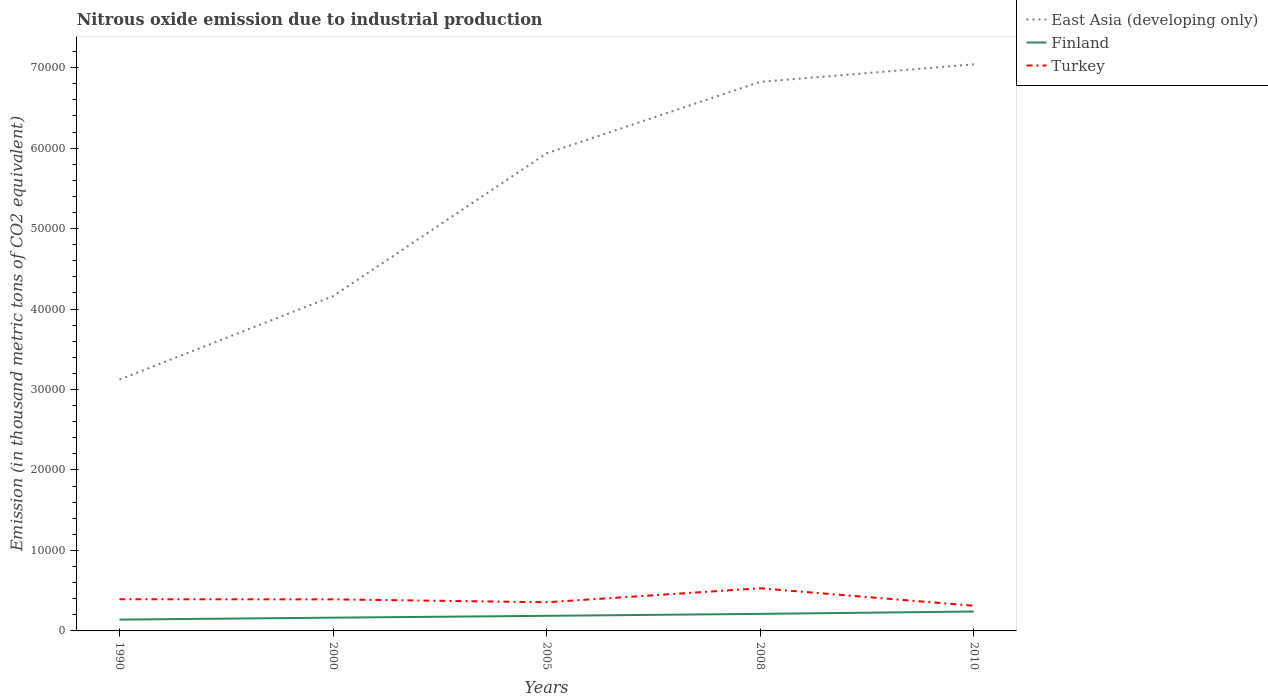How many different coloured lines are there?
Offer a terse response. 3. Does the line corresponding to Finland intersect with the line corresponding to Turkey?
Offer a terse response. No. Across all years, what is the maximum amount of nitrous oxide emitted in Turkey?
Make the answer very short. 3127.4. In which year was the amount of nitrous oxide emitted in Turkey maximum?
Your answer should be compact. 2010. What is the total amount of nitrous oxide emitted in Turkey in the graph?
Make the answer very short. 2172.9. What is the difference between the highest and the second highest amount of nitrous oxide emitted in Turkey?
Your answer should be compact. 2172.9. Is the amount of nitrous oxide emitted in Turkey strictly greater than the amount of nitrous oxide emitted in East Asia (developing only) over the years?
Make the answer very short. Yes. What is the difference between two consecutive major ticks on the Y-axis?
Your answer should be compact. 10000. Where does the legend appear in the graph?
Provide a short and direct response. Top right. What is the title of the graph?
Offer a terse response. Nitrous oxide emission due to industrial production. Does "Trinidad and Tobago" appear as one of the legend labels in the graph?
Keep it short and to the point. No. What is the label or title of the X-axis?
Make the answer very short. Years. What is the label or title of the Y-axis?
Give a very brief answer. Emission (in thousand metric tons of CO2 equivalent). What is the Emission (in thousand metric tons of CO2 equivalent) in East Asia (developing only) in 1990?
Make the answer very short. 3.12e+04. What is the Emission (in thousand metric tons of CO2 equivalent) in Finland in 1990?
Make the answer very short. 1406.8. What is the Emission (in thousand metric tons of CO2 equivalent) in Turkey in 1990?
Ensure brevity in your answer.  3938.1. What is the Emission (in thousand metric tons of CO2 equivalent) in East Asia (developing only) in 2000?
Offer a terse response. 4.16e+04. What is the Emission (in thousand metric tons of CO2 equivalent) of Finland in 2000?
Make the answer very short. 1648.4. What is the Emission (in thousand metric tons of CO2 equivalent) of Turkey in 2000?
Your response must be concise. 3923.9. What is the Emission (in thousand metric tons of CO2 equivalent) in East Asia (developing only) in 2005?
Ensure brevity in your answer.  5.94e+04. What is the Emission (in thousand metric tons of CO2 equivalent) in Finland in 2005?
Offer a very short reply. 1876.3. What is the Emission (in thousand metric tons of CO2 equivalent) of Turkey in 2005?
Give a very brief answer. 3561.4. What is the Emission (in thousand metric tons of CO2 equivalent) in East Asia (developing only) in 2008?
Your response must be concise. 6.82e+04. What is the Emission (in thousand metric tons of CO2 equivalent) in Finland in 2008?
Offer a terse response. 2118.7. What is the Emission (in thousand metric tons of CO2 equivalent) of Turkey in 2008?
Provide a short and direct response. 5300.3. What is the Emission (in thousand metric tons of CO2 equivalent) in East Asia (developing only) in 2010?
Your answer should be compact. 7.04e+04. What is the Emission (in thousand metric tons of CO2 equivalent) of Finland in 2010?
Offer a terse response. 2412.4. What is the Emission (in thousand metric tons of CO2 equivalent) in Turkey in 2010?
Provide a short and direct response. 3127.4. Across all years, what is the maximum Emission (in thousand metric tons of CO2 equivalent) in East Asia (developing only)?
Ensure brevity in your answer.  7.04e+04. Across all years, what is the maximum Emission (in thousand metric tons of CO2 equivalent) of Finland?
Provide a short and direct response. 2412.4. Across all years, what is the maximum Emission (in thousand metric tons of CO2 equivalent) in Turkey?
Give a very brief answer. 5300.3. Across all years, what is the minimum Emission (in thousand metric tons of CO2 equivalent) in East Asia (developing only)?
Offer a terse response. 3.12e+04. Across all years, what is the minimum Emission (in thousand metric tons of CO2 equivalent) of Finland?
Your answer should be very brief. 1406.8. Across all years, what is the minimum Emission (in thousand metric tons of CO2 equivalent) of Turkey?
Provide a short and direct response. 3127.4. What is the total Emission (in thousand metric tons of CO2 equivalent) of East Asia (developing only) in the graph?
Your answer should be compact. 2.71e+05. What is the total Emission (in thousand metric tons of CO2 equivalent) in Finland in the graph?
Offer a very short reply. 9462.6. What is the total Emission (in thousand metric tons of CO2 equivalent) of Turkey in the graph?
Your answer should be very brief. 1.99e+04. What is the difference between the Emission (in thousand metric tons of CO2 equivalent) of East Asia (developing only) in 1990 and that in 2000?
Provide a short and direct response. -1.04e+04. What is the difference between the Emission (in thousand metric tons of CO2 equivalent) of Finland in 1990 and that in 2000?
Provide a short and direct response. -241.6. What is the difference between the Emission (in thousand metric tons of CO2 equivalent) in East Asia (developing only) in 1990 and that in 2005?
Your response must be concise. -2.81e+04. What is the difference between the Emission (in thousand metric tons of CO2 equivalent) of Finland in 1990 and that in 2005?
Your response must be concise. -469.5. What is the difference between the Emission (in thousand metric tons of CO2 equivalent) in Turkey in 1990 and that in 2005?
Offer a terse response. 376.7. What is the difference between the Emission (in thousand metric tons of CO2 equivalent) in East Asia (developing only) in 1990 and that in 2008?
Your answer should be very brief. -3.70e+04. What is the difference between the Emission (in thousand metric tons of CO2 equivalent) of Finland in 1990 and that in 2008?
Keep it short and to the point. -711.9. What is the difference between the Emission (in thousand metric tons of CO2 equivalent) in Turkey in 1990 and that in 2008?
Offer a very short reply. -1362.2. What is the difference between the Emission (in thousand metric tons of CO2 equivalent) of East Asia (developing only) in 1990 and that in 2010?
Your answer should be compact. -3.92e+04. What is the difference between the Emission (in thousand metric tons of CO2 equivalent) in Finland in 1990 and that in 2010?
Give a very brief answer. -1005.6. What is the difference between the Emission (in thousand metric tons of CO2 equivalent) in Turkey in 1990 and that in 2010?
Provide a succinct answer. 810.7. What is the difference between the Emission (in thousand metric tons of CO2 equivalent) of East Asia (developing only) in 2000 and that in 2005?
Ensure brevity in your answer.  -1.78e+04. What is the difference between the Emission (in thousand metric tons of CO2 equivalent) of Finland in 2000 and that in 2005?
Provide a succinct answer. -227.9. What is the difference between the Emission (in thousand metric tons of CO2 equivalent) of Turkey in 2000 and that in 2005?
Keep it short and to the point. 362.5. What is the difference between the Emission (in thousand metric tons of CO2 equivalent) in East Asia (developing only) in 2000 and that in 2008?
Make the answer very short. -2.66e+04. What is the difference between the Emission (in thousand metric tons of CO2 equivalent) of Finland in 2000 and that in 2008?
Your answer should be very brief. -470.3. What is the difference between the Emission (in thousand metric tons of CO2 equivalent) of Turkey in 2000 and that in 2008?
Ensure brevity in your answer.  -1376.4. What is the difference between the Emission (in thousand metric tons of CO2 equivalent) in East Asia (developing only) in 2000 and that in 2010?
Make the answer very short. -2.88e+04. What is the difference between the Emission (in thousand metric tons of CO2 equivalent) of Finland in 2000 and that in 2010?
Give a very brief answer. -764. What is the difference between the Emission (in thousand metric tons of CO2 equivalent) in Turkey in 2000 and that in 2010?
Provide a short and direct response. 796.5. What is the difference between the Emission (in thousand metric tons of CO2 equivalent) of East Asia (developing only) in 2005 and that in 2008?
Ensure brevity in your answer.  -8880.6. What is the difference between the Emission (in thousand metric tons of CO2 equivalent) of Finland in 2005 and that in 2008?
Keep it short and to the point. -242.4. What is the difference between the Emission (in thousand metric tons of CO2 equivalent) of Turkey in 2005 and that in 2008?
Make the answer very short. -1738.9. What is the difference between the Emission (in thousand metric tons of CO2 equivalent) in East Asia (developing only) in 2005 and that in 2010?
Your response must be concise. -1.11e+04. What is the difference between the Emission (in thousand metric tons of CO2 equivalent) of Finland in 2005 and that in 2010?
Give a very brief answer. -536.1. What is the difference between the Emission (in thousand metric tons of CO2 equivalent) in Turkey in 2005 and that in 2010?
Provide a short and direct response. 434. What is the difference between the Emission (in thousand metric tons of CO2 equivalent) of East Asia (developing only) in 2008 and that in 2010?
Your answer should be compact. -2177.7. What is the difference between the Emission (in thousand metric tons of CO2 equivalent) of Finland in 2008 and that in 2010?
Give a very brief answer. -293.7. What is the difference between the Emission (in thousand metric tons of CO2 equivalent) of Turkey in 2008 and that in 2010?
Give a very brief answer. 2172.9. What is the difference between the Emission (in thousand metric tons of CO2 equivalent) in East Asia (developing only) in 1990 and the Emission (in thousand metric tons of CO2 equivalent) in Finland in 2000?
Your response must be concise. 2.96e+04. What is the difference between the Emission (in thousand metric tons of CO2 equivalent) in East Asia (developing only) in 1990 and the Emission (in thousand metric tons of CO2 equivalent) in Turkey in 2000?
Give a very brief answer. 2.73e+04. What is the difference between the Emission (in thousand metric tons of CO2 equivalent) in Finland in 1990 and the Emission (in thousand metric tons of CO2 equivalent) in Turkey in 2000?
Provide a short and direct response. -2517.1. What is the difference between the Emission (in thousand metric tons of CO2 equivalent) in East Asia (developing only) in 1990 and the Emission (in thousand metric tons of CO2 equivalent) in Finland in 2005?
Offer a very short reply. 2.94e+04. What is the difference between the Emission (in thousand metric tons of CO2 equivalent) of East Asia (developing only) in 1990 and the Emission (in thousand metric tons of CO2 equivalent) of Turkey in 2005?
Your response must be concise. 2.77e+04. What is the difference between the Emission (in thousand metric tons of CO2 equivalent) of Finland in 1990 and the Emission (in thousand metric tons of CO2 equivalent) of Turkey in 2005?
Your answer should be compact. -2154.6. What is the difference between the Emission (in thousand metric tons of CO2 equivalent) in East Asia (developing only) in 1990 and the Emission (in thousand metric tons of CO2 equivalent) in Finland in 2008?
Offer a very short reply. 2.91e+04. What is the difference between the Emission (in thousand metric tons of CO2 equivalent) of East Asia (developing only) in 1990 and the Emission (in thousand metric tons of CO2 equivalent) of Turkey in 2008?
Your response must be concise. 2.59e+04. What is the difference between the Emission (in thousand metric tons of CO2 equivalent) of Finland in 1990 and the Emission (in thousand metric tons of CO2 equivalent) of Turkey in 2008?
Provide a short and direct response. -3893.5. What is the difference between the Emission (in thousand metric tons of CO2 equivalent) in East Asia (developing only) in 1990 and the Emission (in thousand metric tons of CO2 equivalent) in Finland in 2010?
Give a very brief answer. 2.88e+04. What is the difference between the Emission (in thousand metric tons of CO2 equivalent) of East Asia (developing only) in 1990 and the Emission (in thousand metric tons of CO2 equivalent) of Turkey in 2010?
Make the answer very short. 2.81e+04. What is the difference between the Emission (in thousand metric tons of CO2 equivalent) of Finland in 1990 and the Emission (in thousand metric tons of CO2 equivalent) of Turkey in 2010?
Provide a succinct answer. -1720.6. What is the difference between the Emission (in thousand metric tons of CO2 equivalent) in East Asia (developing only) in 2000 and the Emission (in thousand metric tons of CO2 equivalent) in Finland in 2005?
Give a very brief answer. 3.97e+04. What is the difference between the Emission (in thousand metric tons of CO2 equivalent) of East Asia (developing only) in 2000 and the Emission (in thousand metric tons of CO2 equivalent) of Turkey in 2005?
Make the answer very short. 3.80e+04. What is the difference between the Emission (in thousand metric tons of CO2 equivalent) of Finland in 2000 and the Emission (in thousand metric tons of CO2 equivalent) of Turkey in 2005?
Your answer should be very brief. -1913. What is the difference between the Emission (in thousand metric tons of CO2 equivalent) in East Asia (developing only) in 2000 and the Emission (in thousand metric tons of CO2 equivalent) in Finland in 2008?
Keep it short and to the point. 3.95e+04. What is the difference between the Emission (in thousand metric tons of CO2 equivalent) in East Asia (developing only) in 2000 and the Emission (in thousand metric tons of CO2 equivalent) in Turkey in 2008?
Keep it short and to the point. 3.63e+04. What is the difference between the Emission (in thousand metric tons of CO2 equivalent) in Finland in 2000 and the Emission (in thousand metric tons of CO2 equivalent) in Turkey in 2008?
Your response must be concise. -3651.9. What is the difference between the Emission (in thousand metric tons of CO2 equivalent) in East Asia (developing only) in 2000 and the Emission (in thousand metric tons of CO2 equivalent) in Finland in 2010?
Offer a terse response. 3.92e+04. What is the difference between the Emission (in thousand metric tons of CO2 equivalent) of East Asia (developing only) in 2000 and the Emission (in thousand metric tons of CO2 equivalent) of Turkey in 2010?
Provide a short and direct response. 3.85e+04. What is the difference between the Emission (in thousand metric tons of CO2 equivalent) of Finland in 2000 and the Emission (in thousand metric tons of CO2 equivalent) of Turkey in 2010?
Your response must be concise. -1479. What is the difference between the Emission (in thousand metric tons of CO2 equivalent) in East Asia (developing only) in 2005 and the Emission (in thousand metric tons of CO2 equivalent) in Finland in 2008?
Provide a succinct answer. 5.72e+04. What is the difference between the Emission (in thousand metric tons of CO2 equivalent) in East Asia (developing only) in 2005 and the Emission (in thousand metric tons of CO2 equivalent) in Turkey in 2008?
Provide a short and direct response. 5.41e+04. What is the difference between the Emission (in thousand metric tons of CO2 equivalent) in Finland in 2005 and the Emission (in thousand metric tons of CO2 equivalent) in Turkey in 2008?
Your answer should be very brief. -3424. What is the difference between the Emission (in thousand metric tons of CO2 equivalent) of East Asia (developing only) in 2005 and the Emission (in thousand metric tons of CO2 equivalent) of Finland in 2010?
Provide a short and direct response. 5.69e+04. What is the difference between the Emission (in thousand metric tons of CO2 equivalent) in East Asia (developing only) in 2005 and the Emission (in thousand metric tons of CO2 equivalent) in Turkey in 2010?
Your answer should be compact. 5.62e+04. What is the difference between the Emission (in thousand metric tons of CO2 equivalent) in Finland in 2005 and the Emission (in thousand metric tons of CO2 equivalent) in Turkey in 2010?
Offer a terse response. -1251.1. What is the difference between the Emission (in thousand metric tons of CO2 equivalent) in East Asia (developing only) in 2008 and the Emission (in thousand metric tons of CO2 equivalent) in Finland in 2010?
Make the answer very short. 6.58e+04. What is the difference between the Emission (in thousand metric tons of CO2 equivalent) in East Asia (developing only) in 2008 and the Emission (in thousand metric tons of CO2 equivalent) in Turkey in 2010?
Give a very brief answer. 6.51e+04. What is the difference between the Emission (in thousand metric tons of CO2 equivalent) in Finland in 2008 and the Emission (in thousand metric tons of CO2 equivalent) in Turkey in 2010?
Make the answer very short. -1008.7. What is the average Emission (in thousand metric tons of CO2 equivalent) of East Asia (developing only) per year?
Your response must be concise. 5.42e+04. What is the average Emission (in thousand metric tons of CO2 equivalent) in Finland per year?
Ensure brevity in your answer.  1892.52. What is the average Emission (in thousand metric tons of CO2 equivalent) of Turkey per year?
Your response must be concise. 3970.22. In the year 1990, what is the difference between the Emission (in thousand metric tons of CO2 equivalent) in East Asia (developing only) and Emission (in thousand metric tons of CO2 equivalent) in Finland?
Keep it short and to the point. 2.98e+04. In the year 1990, what is the difference between the Emission (in thousand metric tons of CO2 equivalent) in East Asia (developing only) and Emission (in thousand metric tons of CO2 equivalent) in Turkey?
Offer a terse response. 2.73e+04. In the year 1990, what is the difference between the Emission (in thousand metric tons of CO2 equivalent) of Finland and Emission (in thousand metric tons of CO2 equivalent) of Turkey?
Your response must be concise. -2531.3. In the year 2000, what is the difference between the Emission (in thousand metric tons of CO2 equivalent) of East Asia (developing only) and Emission (in thousand metric tons of CO2 equivalent) of Finland?
Provide a short and direct response. 3.99e+04. In the year 2000, what is the difference between the Emission (in thousand metric tons of CO2 equivalent) of East Asia (developing only) and Emission (in thousand metric tons of CO2 equivalent) of Turkey?
Ensure brevity in your answer.  3.77e+04. In the year 2000, what is the difference between the Emission (in thousand metric tons of CO2 equivalent) of Finland and Emission (in thousand metric tons of CO2 equivalent) of Turkey?
Keep it short and to the point. -2275.5. In the year 2005, what is the difference between the Emission (in thousand metric tons of CO2 equivalent) in East Asia (developing only) and Emission (in thousand metric tons of CO2 equivalent) in Finland?
Keep it short and to the point. 5.75e+04. In the year 2005, what is the difference between the Emission (in thousand metric tons of CO2 equivalent) in East Asia (developing only) and Emission (in thousand metric tons of CO2 equivalent) in Turkey?
Ensure brevity in your answer.  5.58e+04. In the year 2005, what is the difference between the Emission (in thousand metric tons of CO2 equivalent) in Finland and Emission (in thousand metric tons of CO2 equivalent) in Turkey?
Your answer should be compact. -1685.1. In the year 2008, what is the difference between the Emission (in thousand metric tons of CO2 equivalent) in East Asia (developing only) and Emission (in thousand metric tons of CO2 equivalent) in Finland?
Your response must be concise. 6.61e+04. In the year 2008, what is the difference between the Emission (in thousand metric tons of CO2 equivalent) in East Asia (developing only) and Emission (in thousand metric tons of CO2 equivalent) in Turkey?
Keep it short and to the point. 6.29e+04. In the year 2008, what is the difference between the Emission (in thousand metric tons of CO2 equivalent) in Finland and Emission (in thousand metric tons of CO2 equivalent) in Turkey?
Keep it short and to the point. -3181.6. In the year 2010, what is the difference between the Emission (in thousand metric tons of CO2 equivalent) in East Asia (developing only) and Emission (in thousand metric tons of CO2 equivalent) in Finland?
Make the answer very short. 6.80e+04. In the year 2010, what is the difference between the Emission (in thousand metric tons of CO2 equivalent) of East Asia (developing only) and Emission (in thousand metric tons of CO2 equivalent) of Turkey?
Offer a very short reply. 6.73e+04. In the year 2010, what is the difference between the Emission (in thousand metric tons of CO2 equivalent) in Finland and Emission (in thousand metric tons of CO2 equivalent) in Turkey?
Keep it short and to the point. -715. What is the ratio of the Emission (in thousand metric tons of CO2 equivalent) in East Asia (developing only) in 1990 to that in 2000?
Offer a very short reply. 0.75. What is the ratio of the Emission (in thousand metric tons of CO2 equivalent) of Finland in 1990 to that in 2000?
Your response must be concise. 0.85. What is the ratio of the Emission (in thousand metric tons of CO2 equivalent) in East Asia (developing only) in 1990 to that in 2005?
Offer a very short reply. 0.53. What is the ratio of the Emission (in thousand metric tons of CO2 equivalent) of Finland in 1990 to that in 2005?
Your answer should be compact. 0.75. What is the ratio of the Emission (in thousand metric tons of CO2 equivalent) in Turkey in 1990 to that in 2005?
Offer a very short reply. 1.11. What is the ratio of the Emission (in thousand metric tons of CO2 equivalent) in East Asia (developing only) in 1990 to that in 2008?
Your answer should be very brief. 0.46. What is the ratio of the Emission (in thousand metric tons of CO2 equivalent) in Finland in 1990 to that in 2008?
Keep it short and to the point. 0.66. What is the ratio of the Emission (in thousand metric tons of CO2 equivalent) of Turkey in 1990 to that in 2008?
Offer a terse response. 0.74. What is the ratio of the Emission (in thousand metric tons of CO2 equivalent) in East Asia (developing only) in 1990 to that in 2010?
Offer a terse response. 0.44. What is the ratio of the Emission (in thousand metric tons of CO2 equivalent) in Finland in 1990 to that in 2010?
Provide a short and direct response. 0.58. What is the ratio of the Emission (in thousand metric tons of CO2 equivalent) of Turkey in 1990 to that in 2010?
Keep it short and to the point. 1.26. What is the ratio of the Emission (in thousand metric tons of CO2 equivalent) in East Asia (developing only) in 2000 to that in 2005?
Give a very brief answer. 0.7. What is the ratio of the Emission (in thousand metric tons of CO2 equivalent) in Finland in 2000 to that in 2005?
Offer a very short reply. 0.88. What is the ratio of the Emission (in thousand metric tons of CO2 equivalent) of Turkey in 2000 to that in 2005?
Your response must be concise. 1.1. What is the ratio of the Emission (in thousand metric tons of CO2 equivalent) in East Asia (developing only) in 2000 to that in 2008?
Provide a succinct answer. 0.61. What is the ratio of the Emission (in thousand metric tons of CO2 equivalent) in Finland in 2000 to that in 2008?
Your response must be concise. 0.78. What is the ratio of the Emission (in thousand metric tons of CO2 equivalent) of Turkey in 2000 to that in 2008?
Your response must be concise. 0.74. What is the ratio of the Emission (in thousand metric tons of CO2 equivalent) of East Asia (developing only) in 2000 to that in 2010?
Offer a very short reply. 0.59. What is the ratio of the Emission (in thousand metric tons of CO2 equivalent) of Finland in 2000 to that in 2010?
Your response must be concise. 0.68. What is the ratio of the Emission (in thousand metric tons of CO2 equivalent) of Turkey in 2000 to that in 2010?
Provide a succinct answer. 1.25. What is the ratio of the Emission (in thousand metric tons of CO2 equivalent) in East Asia (developing only) in 2005 to that in 2008?
Keep it short and to the point. 0.87. What is the ratio of the Emission (in thousand metric tons of CO2 equivalent) of Finland in 2005 to that in 2008?
Ensure brevity in your answer.  0.89. What is the ratio of the Emission (in thousand metric tons of CO2 equivalent) of Turkey in 2005 to that in 2008?
Offer a very short reply. 0.67. What is the ratio of the Emission (in thousand metric tons of CO2 equivalent) in East Asia (developing only) in 2005 to that in 2010?
Offer a terse response. 0.84. What is the ratio of the Emission (in thousand metric tons of CO2 equivalent) in Finland in 2005 to that in 2010?
Make the answer very short. 0.78. What is the ratio of the Emission (in thousand metric tons of CO2 equivalent) of Turkey in 2005 to that in 2010?
Your answer should be very brief. 1.14. What is the ratio of the Emission (in thousand metric tons of CO2 equivalent) in East Asia (developing only) in 2008 to that in 2010?
Make the answer very short. 0.97. What is the ratio of the Emission (in thousand metric tons of CO2 equivalent) of Finland in 2008 to that in 2010?
Your answer should be very brief. 0.88. What is the ratio of the Emission (in thousand metric tons of CO2 equivalent) in Turkey in 2008 to that in 2010?
Offer a terse response. 1.69. What is the difference between the highest and the second highest Emission (in thousand metric tons of CO2 equivalent) of East Asia (developing only)?
Give a very brief answer. 2177.7. What is the difference between the highest and the second highest Emission (in thousand metric tons of CO2 equivalent) in Finland?
Your answer should be compact. 293.7. What is the difference between the highest and the second highest Emission (in thousand metric tons of CO2 equivalent) in Turkey?
Give a very brief answer. 1362.2. What is the difference between the highest and the lowest Emission (in thousand metric tons of CO2 equivalent) of East Asia (developing only)?
Keep it short and to the point. 3.92e+04. What is the difference between the highest and the lowest Emission (in thousand metric tons of CO2 equivalent) of Finland?
Make the answer very short. 1005.6. What is the difference between the highest and the lowest Emission (in thousand metric tons of CO2 equivalent) of Turkey?
Offer a very short reply. 2172.9. 